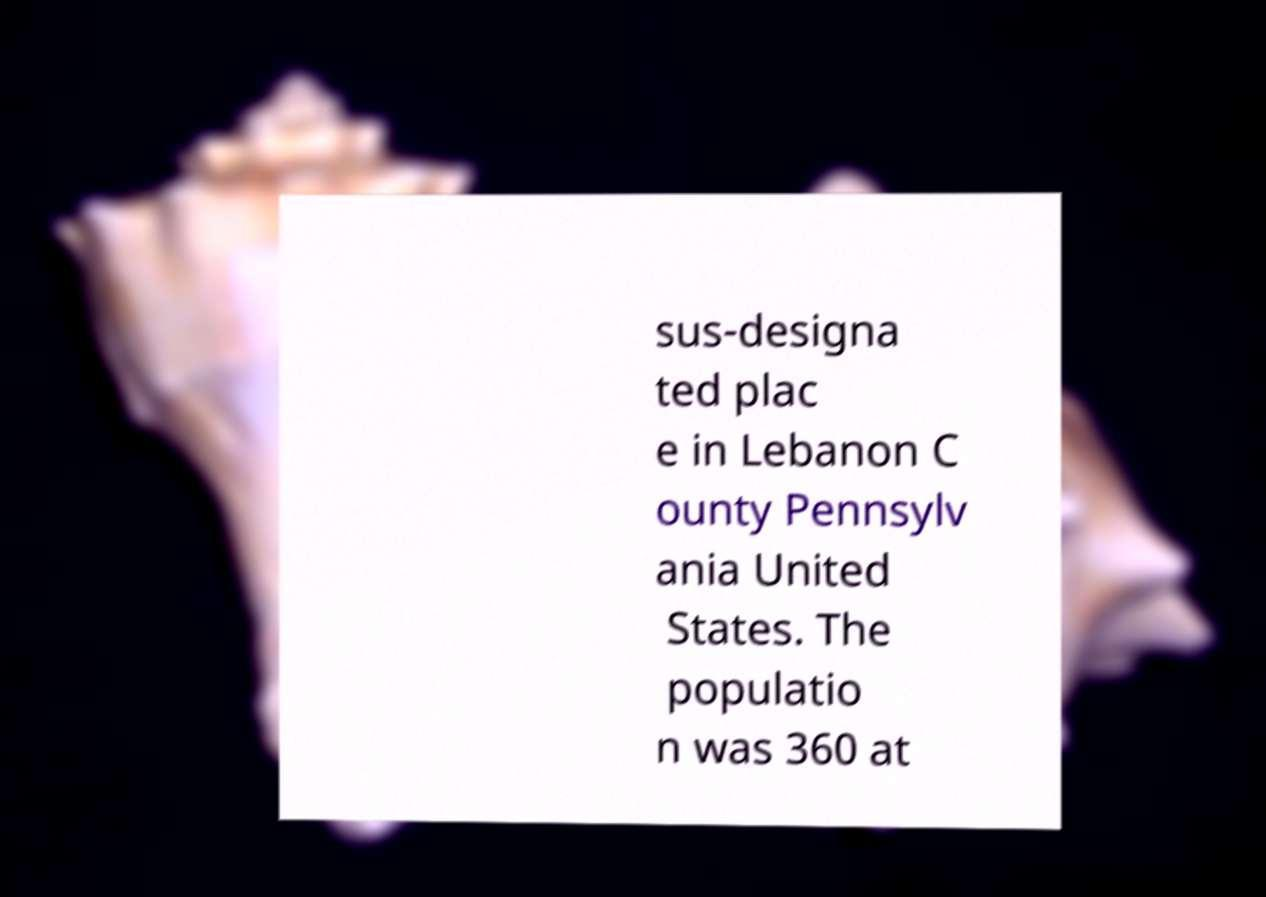For documentation purposes, I need the text within this image transcribed. Could you provide that? sus-designa ted plac e in Lebanon C ounty Pennsylv ania United States. The populatio n was 360 at 